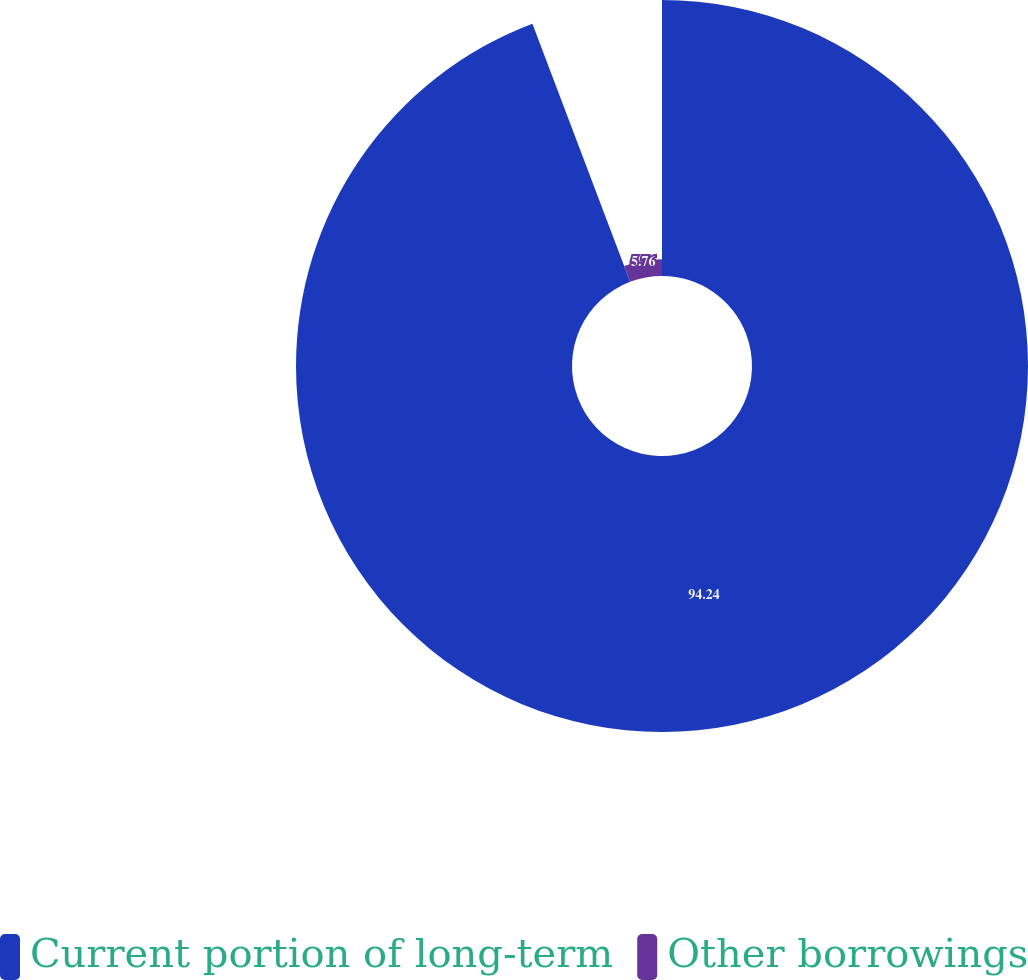<chart> <loc_0><loc_0><loc_500><loc_500><pie_chart><fcel>Current portion of long-term<fcel>Other borrowings<nl><fcel>94.24%<fcel>5.76%<nl></chart> 